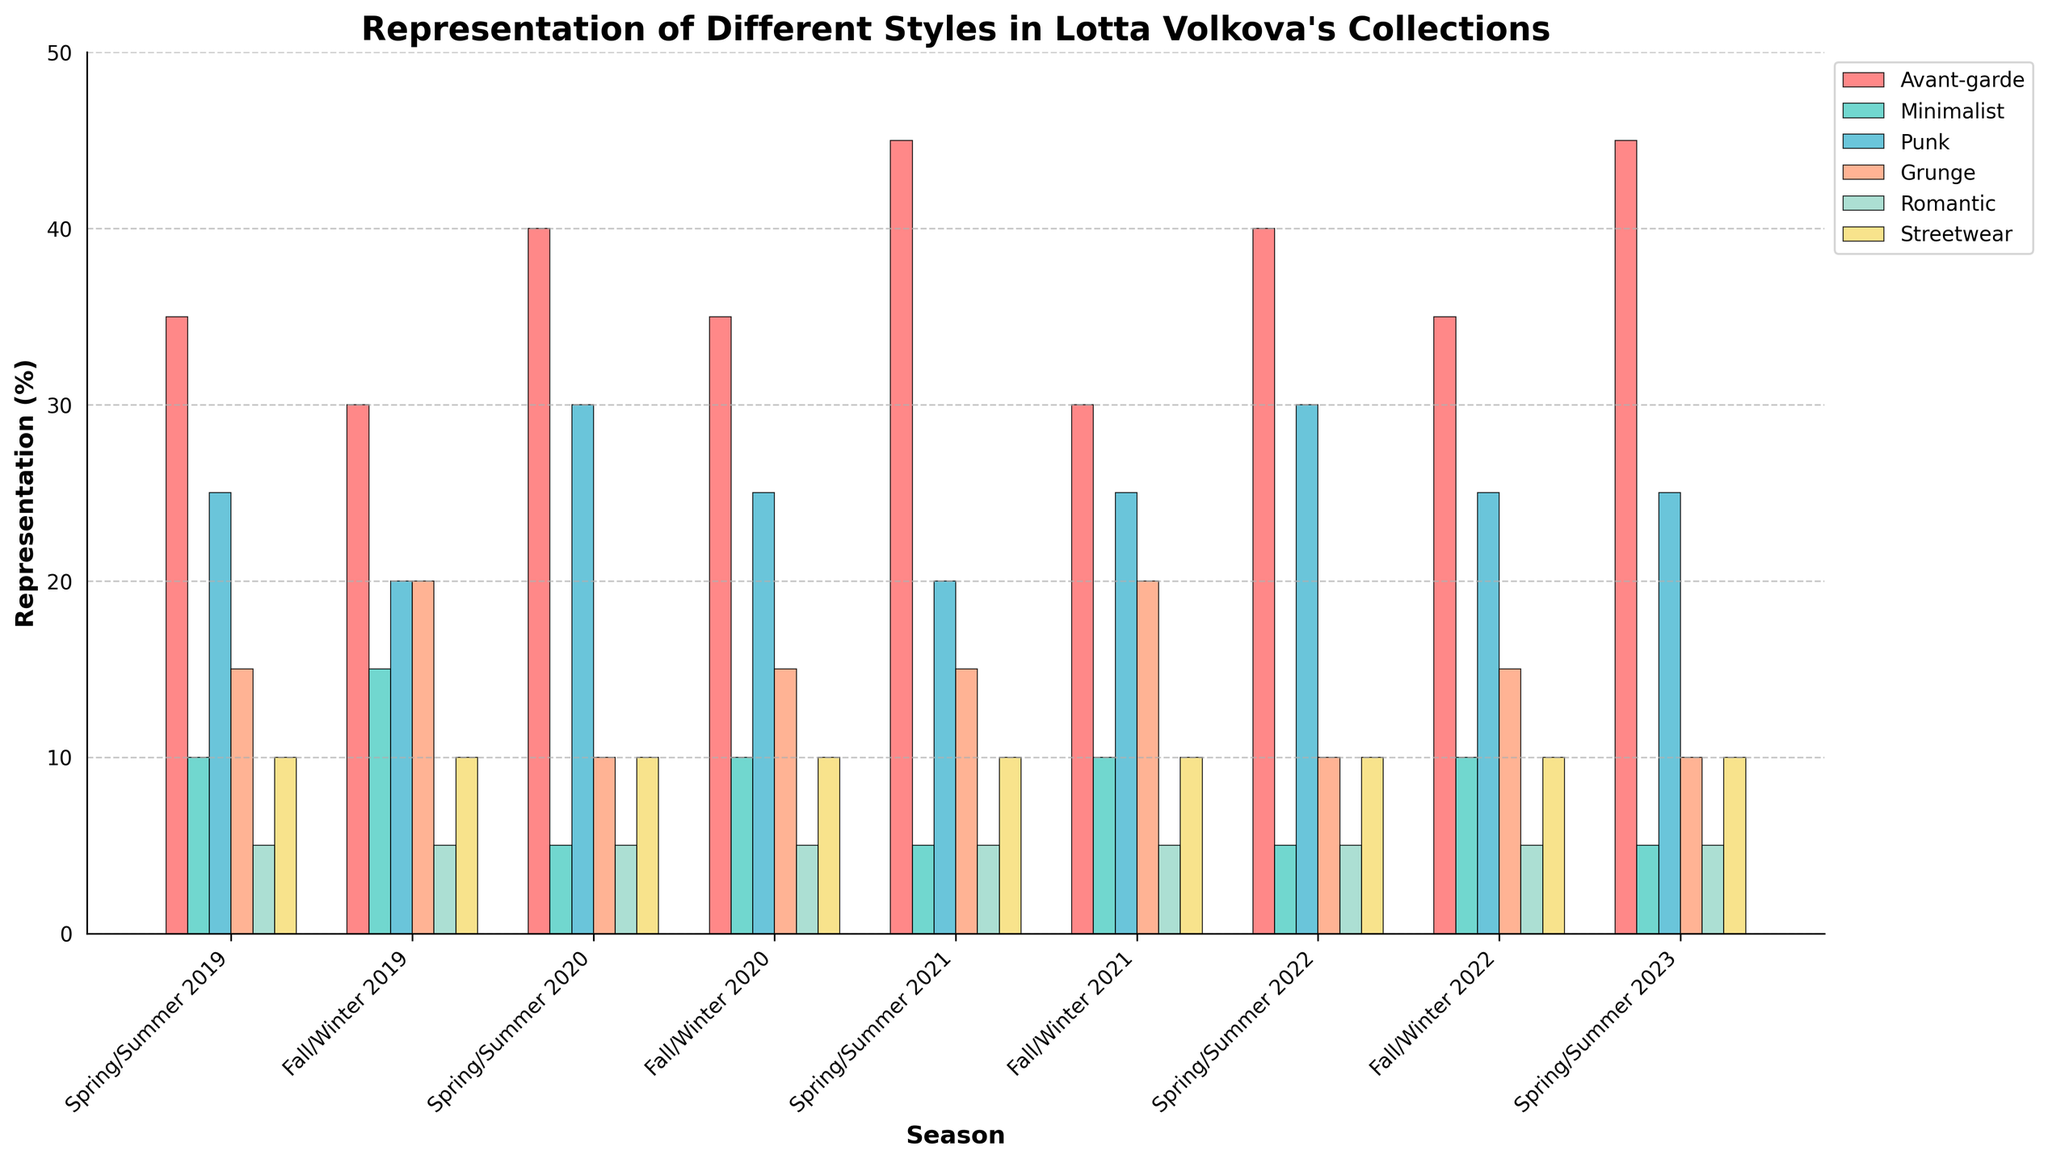Which season has the highest representation of Avant-garde style? Identify the bar representing the highest value in the Avant-garde category and find the corresponding season. The tallest bar in Avant-garde is for Spring/Summer 2021.
Answer: Spring/Summer 2021 Which style sees a consistent representation (almost unchanged) across all seasons? Observe all bars for each style across all seasons and identify the one that stays more or less stable. Romantic style bars show almost the same representation across seasons.
Answer: Romantic How does the representation of Minimalist style in Fall/Winter 2019 compare with Spring/Summer 2019? Compare the height of the Minimalist bar in Fall/Winter 2019 with Spring/Summer 2019. Fall/Winter 2019 has a higher Minimalist representation than Spring/Summer 2019.
Answer: Higher Which style has the greatest increase in representation from Fall/Winter 2019 to Spring/Summer 2020? Calculate the difference in heights of bars for each style between Fall/Winter 2019 and Spring/Summer 2020, then identify the greatest increase. Avant-garde style increased from 30% to 40%, an increase of 10%, which is the largest.
Answer: Avant-garde What's the average representation of the Punk style in 2021? Find the values for Punk in Spring/Summer 2021 and Fall/Winter 2021, sum them up, and divide by 2. The values are 20 and 25; the sum is 45, so the average is 45/2 = 22.5%.
Answer: 22.5% How does Streetwear representation in Spring/Summer 2023 visually compare with the other seasons? Visually compare the height of the Streetwear bar in Spring/Summer 2023 with Streetwear bars in other seasons. It appears to be consistent with other seasons.
Answer: Consistent Which season shows a higher representation of Grunge style, Fall/Winter 2019 or Fall/Winter 2020? Compare the height of the Grunge bars for Fall/Winter 2019 and Fall/Winter 2020. Fall/Winter 2019 is higher at 20% compared to Fall/Winter 2020's 15%.
Answer: Fall/Winter 2019 What is the trend in representation of Minimalist style from Spring/Summer 2020 to Spring/Summer 2022? Observe the height of Minimalist bars from Spring/Summer 2020 through Spring/Summer 2022 and determine the trend. The representation decreases from 5% each season.
Answer: Decreasing Which styles have the same representation percentage in Fall/Winter 2022? Identify the heights of the bars in Fall/Winter 2022 and find those that match. Avant-garde, Punk, and Grunge all have 25%.
Answer: Avant-garde, Punk, Grunge 